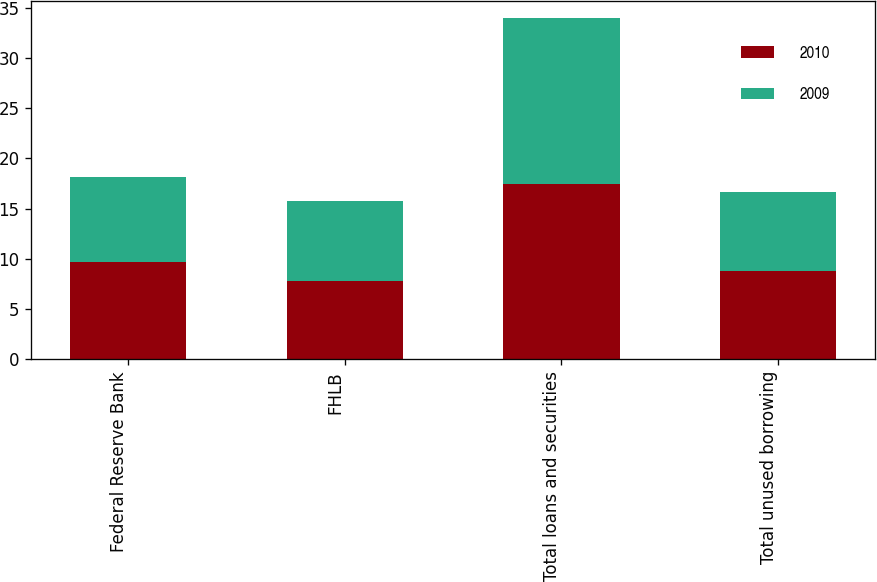<chart> <loc_0><loc_0><loc_500><loc_500><stacked_bar_chart><ecel><fcel>Federal Reserve Bank<fcel>FHLB<fcel>Total loans and securities<fcel>Total unused borrowing<nl><fcel>2010<fcel>9.7<fcel>7.8<fcel>17.5<fcel>8.8<nl><fcel>2009<fcel>8.5<fcel>8<fcel>16.5<fcel>7.9<nl></chart> 